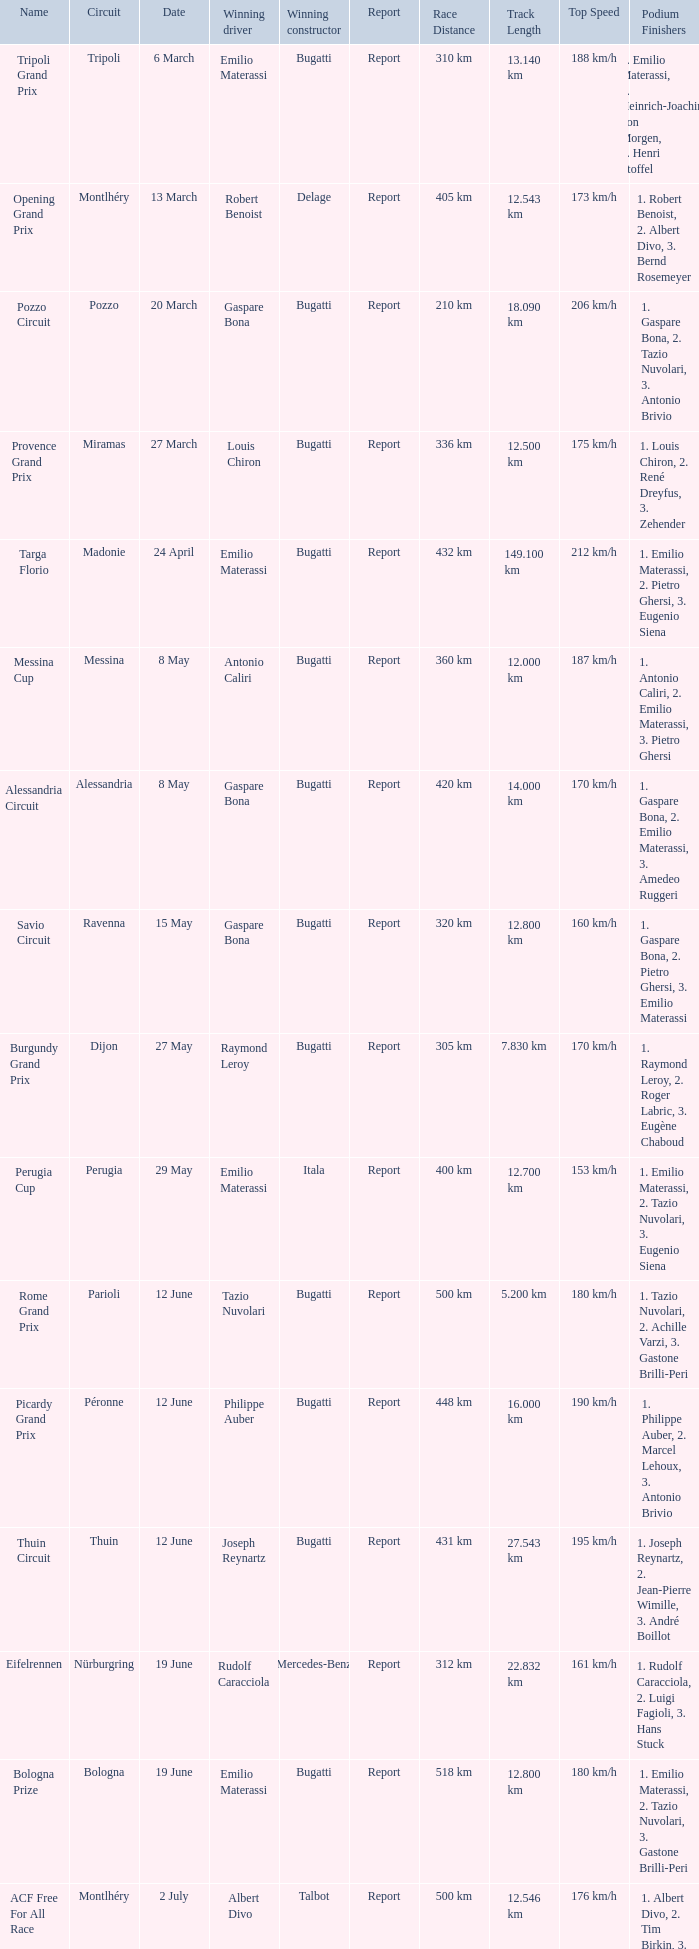Who was the winning constructor of the Grand Prix Du Salon ? La Licorne. 